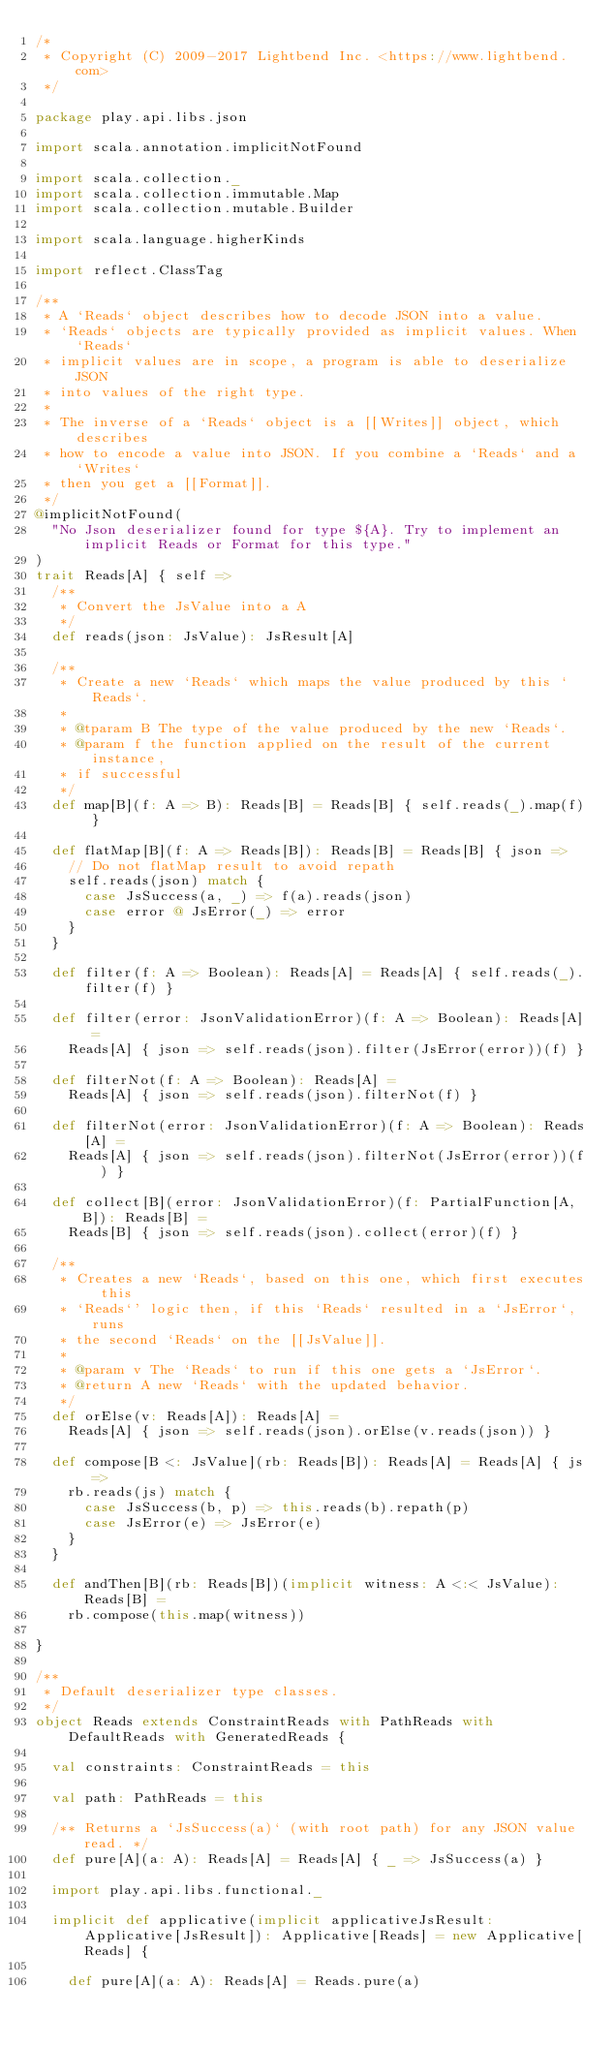<code> <loc_0><loc_0><loc_500><loc_500><_Scala_>/*
 * Copyright (C) 2009-2017 Lightbend Inc. <https://www.lightbend.com>
 */

package play.api.libs.json

import scala.annotation.implicitNotFound

import scala.collection._
import scala.collection.immutable.Map
import scala.collection.mutable.Builder

import scala.language.higherKinds

import reflect.ClassTag

/**
 * A `Reads` object describes how to decode JSON into a value.
 * `Reads` objects are typically provided as implicit values. When `Reads`
 * implicit values are in scope, a program is able to deserialize JSON
 * into values of the right type.
 *
 * The inverse of a `Reads` object is a [[Writes]] object, which describes
 * how to encode a value into JSON. If you combine a `Reads` and a `Writes`
 * then you get a [[Format]].
 */
@implicitNotFound(
  "No Json deserializer found for type ${A}. Try to implement an implicit Reads or Format for this type."
)
trait Reads[A] { self =>
  /**
   * Convert the JsValue into a A
   */
  def reads(json: JsValue): JsResult[A]

  /**
   * Create a new `Reads` which maps the value produced by this `Reads`.
   *
   * @tparam B The type of the value produced by the new `Reads`.
   * @param f the function applied on the result of the current instance,
   * if successful
   */
  def map[B](f: A => B): Reads[B] = Reads[B] { self.reads(_).map(f) }

  def flatMap[B](f: A => Reads[B]): Reads[B] = Reads[B] { json =>
    // Do not flatMap result to avoid repath
    self.reads(json) match {
      case JsSuccess(a, _) => f(a).reads(json)
      case error @ JsError(_) => error
    }
  }

  def filter(f: A => Boolean): Reads[A] = Reads[A] { self.reads(_).filter(f) }

  def filter(error: JsonValidationError)(f: A => Boolean): Reads[A] =
    Reads[A] { json => self.reads(json).filter(JsError(error))(f) }

  def filterNot(f: A => Boolean): Reads[A] =
    Reads[A] { json => self.reads(json).filterNot(f) }

  def filterNot(error: JsonValidationError)(f: A => Boolean): Reads[A] =
    Reads[A] { json => self.reads(json).filterNot(JsError(error))(f) }

  def collect[B](error: JsonValidationError)(f: PartialFunction[A, B]): Reads[B] =
    Reads[B] { json => self.reads(json).collect(error)(f) }

  /**
   * Creates a new `Reads`, based on this one, which first executes this
   * `Reads`' logic then, if this `Reads` resulted in a `JsError`, runs
   * the second `Reads` on the [[JsValue]].
   *
   * @param v The `Reads` to run if this one gets a `JsError`.
   * @return A new `Reads` with the updated behavior.
   */
  def orElse(v: Reads[A]): Reads[A] =
    Reads[A] { json => self.reads(json).orElse(v.reads(json)) }

  def compose[B <: JsValue](rb: Reads[B]): Reads[A] = Reads[A] { js =>
    rb.reads(js) match {
      case JsSuccess(b, p) => this.reads(b).repath(p)
      case JsError(e) => JsError(e)
    }
  }

  def andThen[B](rb: Reads[B])(implicit witness: A <:< JsValue): Reads[B] =
    rb.compose(this.map(witness))

}

/**
 * Default deserializer type classes.
 */
object Reads extends ConstraintReads with PathReads with DefaultReads with GeneratedReads {

  val constraints: ConstraintReads = this

  val path: PathReads = this

  /** Returns a `JsSuccess(a)` (with root path) for any JSON value read. */
  def pure[A](a: A): Reads[A] = Reads[A] { _ => JsSuccess(a) }

  import play.api.libs.functional._

  implicit def applicative(implicit applicativeJsResult: Applicative[JsResult]): Applicative[Reads] = new Applicative[Reads] {

    def pure[A](a: A): Reads[A] = Reads.pure(a)
</code> 